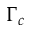<formula> <loc_0><loc_0><loc_500><loc_500>\Gamma _ { c }</formula> 